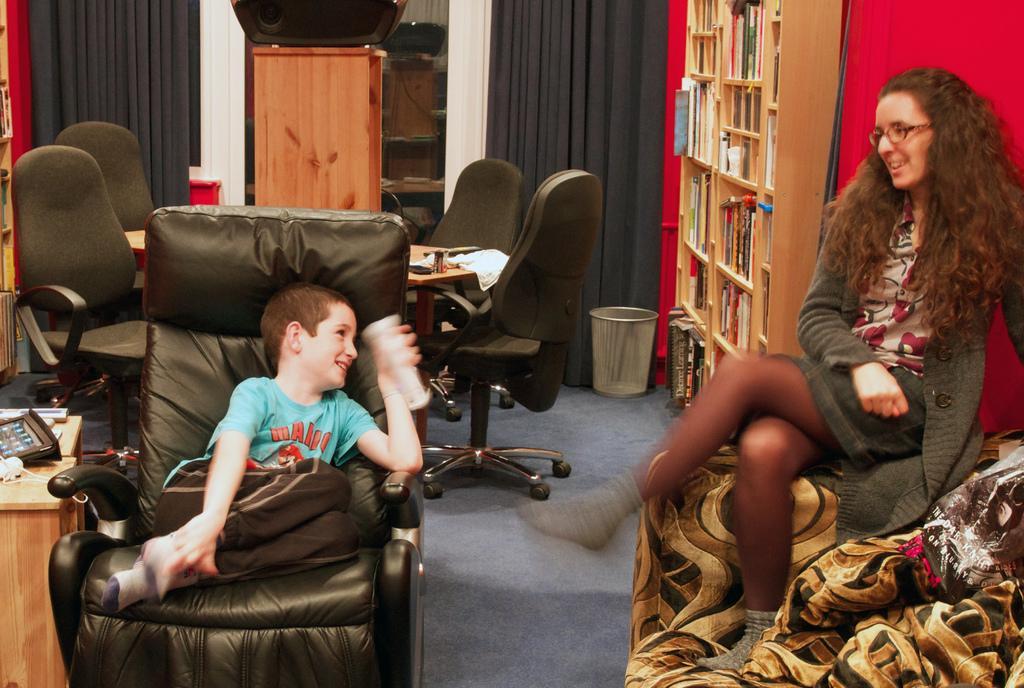In one or two sentences, can you explain what this image depicts? This picture is clicked inside the room. The boy in blue T-shirt is holding something in his hand. He is sitting on the chair and he is smiling. Beside him, we see a table on which black color object is placed. On the right side, the woman in black jacket is sitting on the sofa. Behind her, we see a red wall. Beside that, we see a rack in which books are placed. Beside that, we see a black curtain and a dustbin. In the middle of the picture, we see a table around which chairs are placed. Behind that, we see a cupboard and a black curtain. 